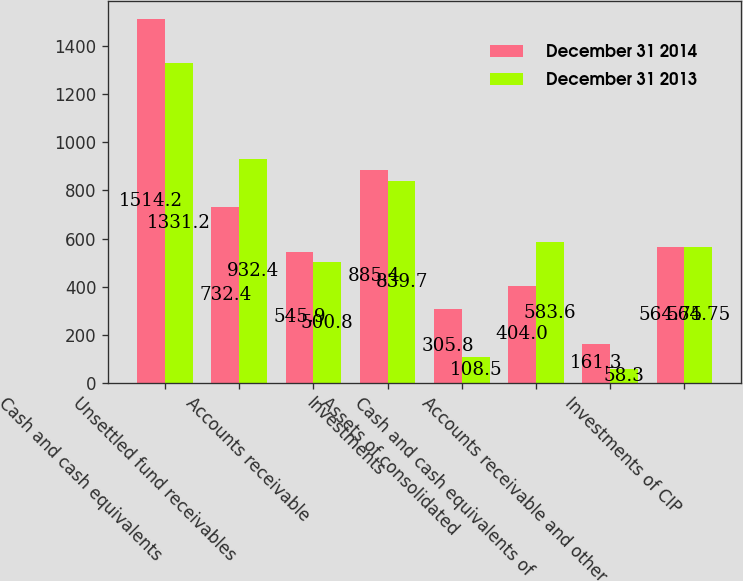Convert chart to OTSL. <chart><loc_0><loc_0><loc_500><loc_500><stacked_bar_chart><ecel><fcel>Cash and cash equivalents<fcel>Unsettled fund receivables<fcel>Accounts receivable<fcel>Investments<fcel>Assets of consolidated<fcel>Cash and cash equivalents of<fcel>Accounts receivable and other<fcel>Investments of CIP<nl><fcel>December 31 2014<fcel>1514.2<fcel>732.4<fcel>545.9<fcel>885.4<fcel>305.8<fcel>404<fcel>161.3<fcel>564.75<nl><fcel>December 31 2013<fcel>1331.2<fcel>932.4<fcel>500.8<fcel>839.7<fcel>108.5<fcel>583.6<fcel>58.3<fcel>564.75<nl></chart> 